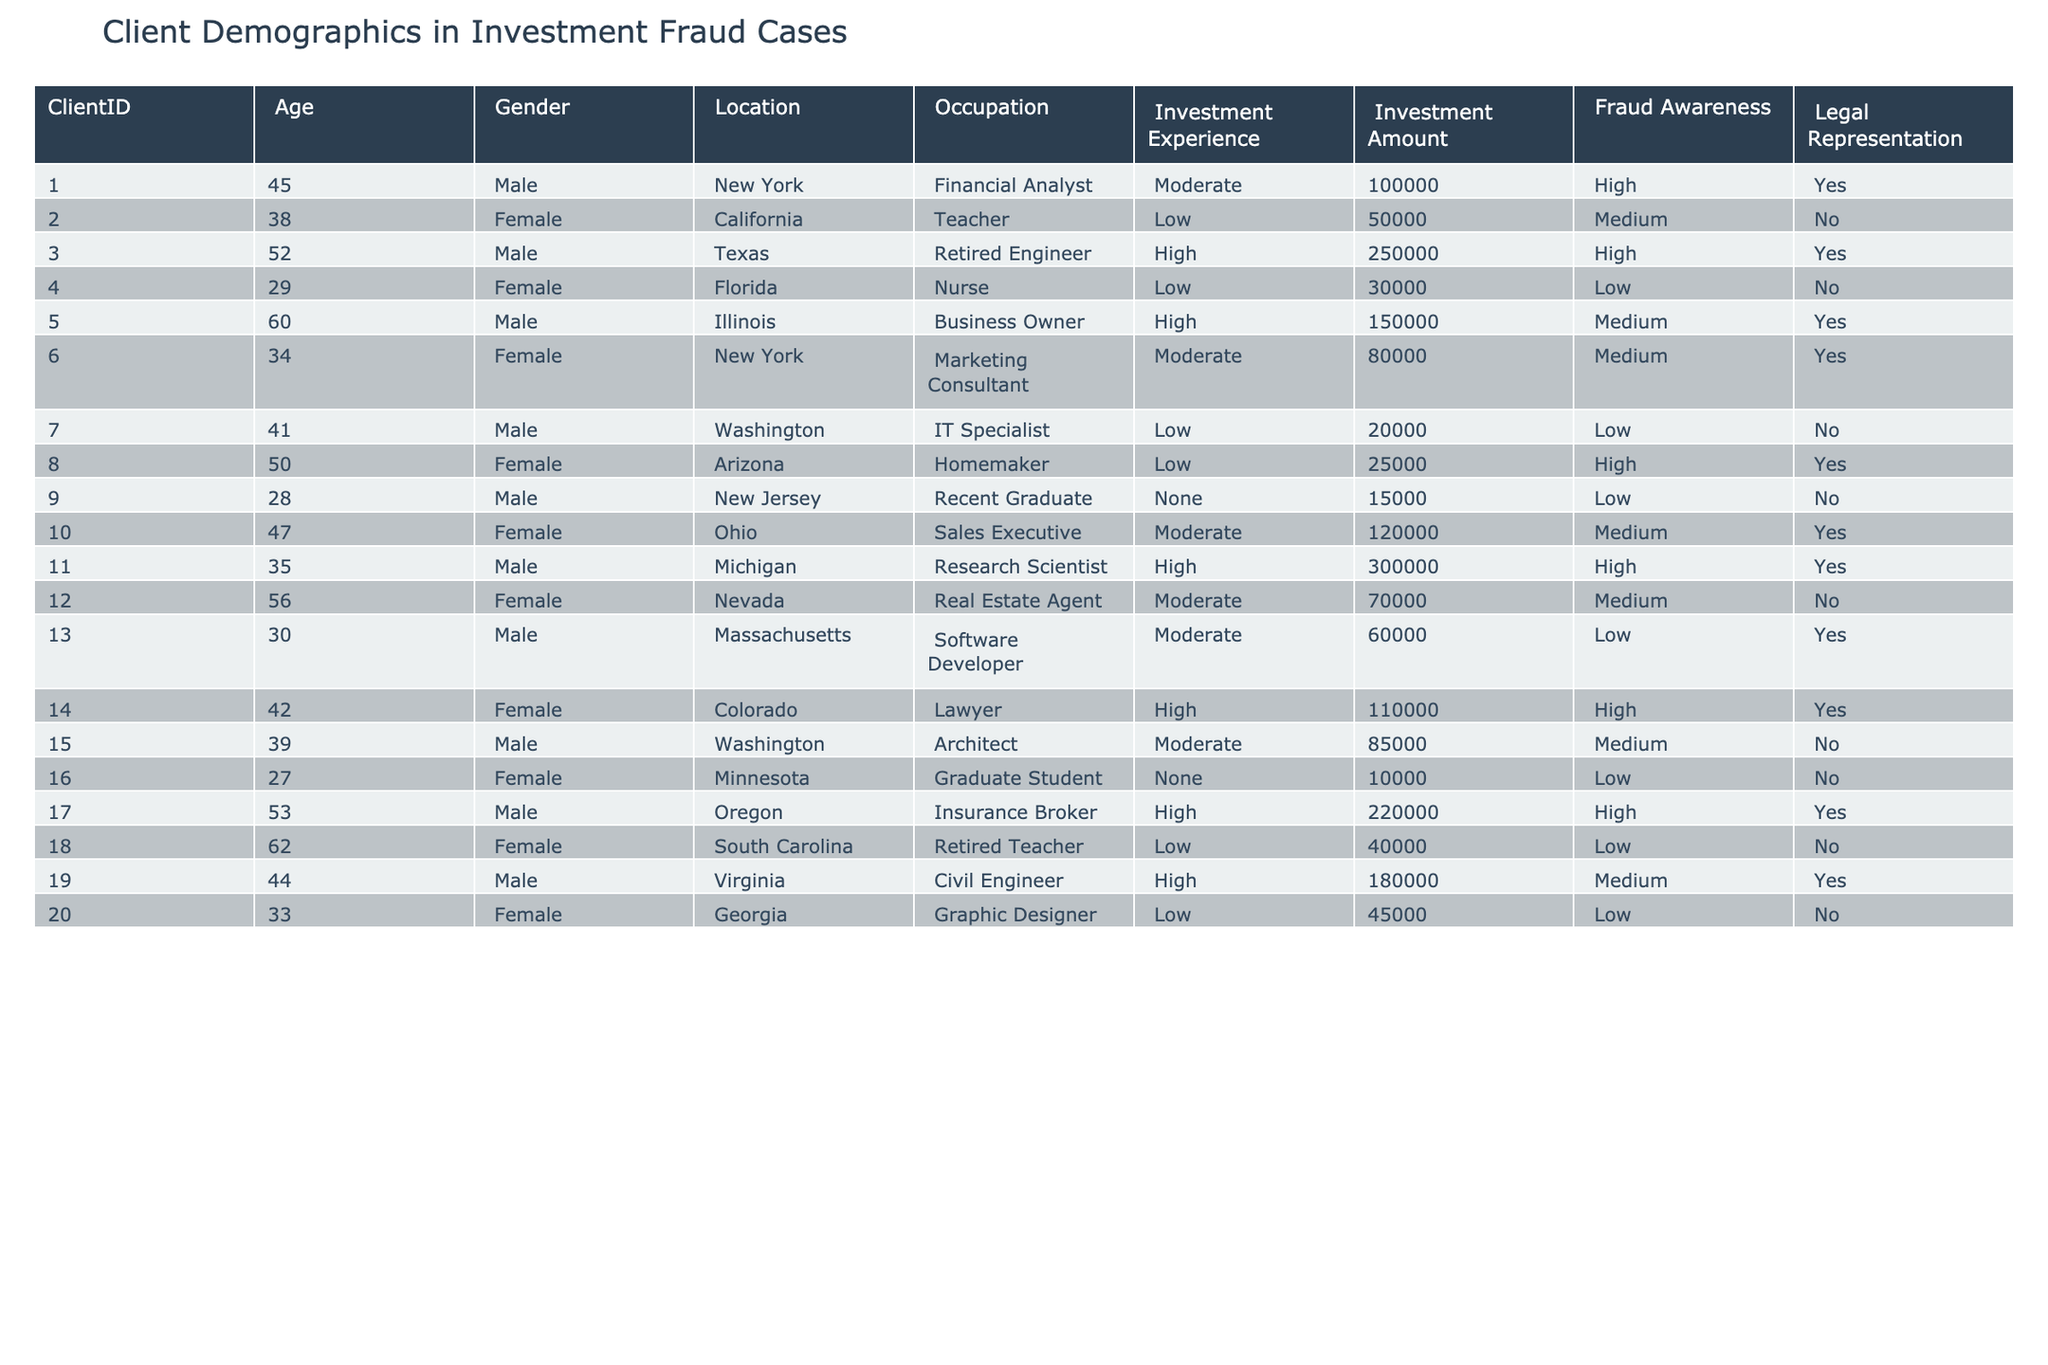What is the total investment amount from clients with high fraud awareness? From the table, we identify clients with high fraud awareness: ClientID 1 (100000), 3 (250000), 5 (150000), 11 (300000), 14 (110000), 17 (220000), and 19 (180000). Adding these amounts gives: 100000 + 250000 + 150000 + 300000 + 110000 + 220000 + 180000 = 1310000.
Answer: 1310000 How many male clients are represented in the table? By scanning the Gender column, we count males: ClientID 1, 3, 5, 7, 11, 13, 15, 17, 19. This results in a total of 9 male clients.
Answer: 9 What is the average age of clients with legal representation? We first identify clients with legal representation: ClientID's 1, 3, 5, 6, 10, 11, 14, 17. Their ages are 45, 52, 60, 34, 47, 35, 42, 53. The average is calculated as (45 + 52 + 60 + 34 + 47 + 35 + 42 + 53) / 8 = 46.75.
Answer: 46.75 Is there a client with no investment experience and high fraud awareness? Examining the Investment Experience and Fraud Awareness columns, we find ClientID 9, who has no investment experience but a low fraud awareness, thus no, there is no such client.
Answer: No What percentage of clients are from New York? There are 2 clients from New York (ClientID 1 and 6) out of a total of 20 clients. The calculation is (2/20) * 100 = 10%.
Answer: 10% 